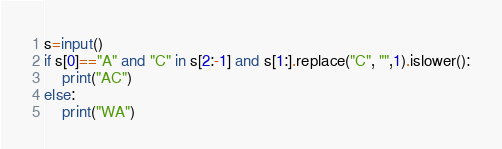Convert code to text. <code><loc_0><loc_0><loc_500><loc_500><_Python_>s=input()
if s[0]=="A" and "C" in s[2:-1] and s[1:].replace("C", "",1).islower():
    print("AC")
else:
    print("WA")</code> 